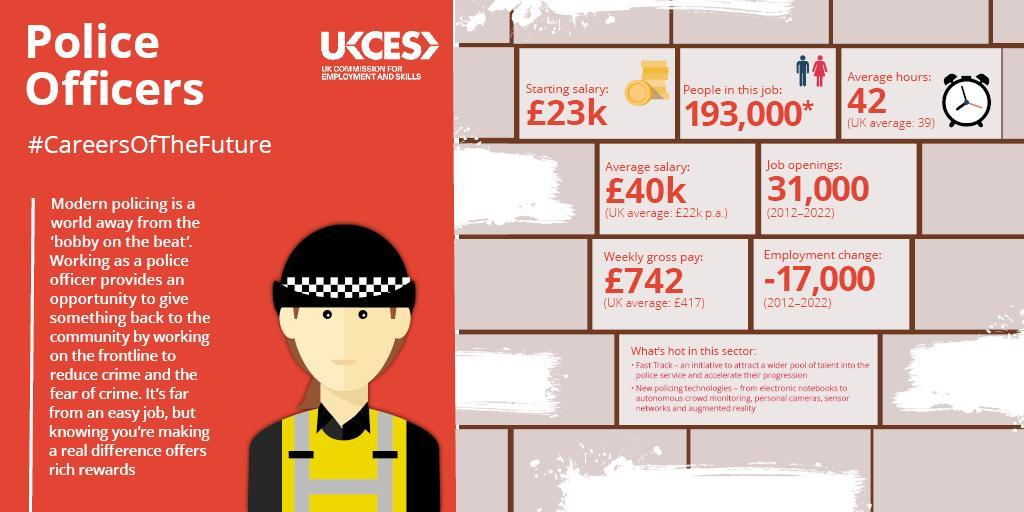How many people are working as police officers in UK?
Answer the question with a short phrase. 193,000* What is the starting salary of a police officer in UK? £23k What is the number of job openings in police service in UK  from 2011-2022? 31,000 